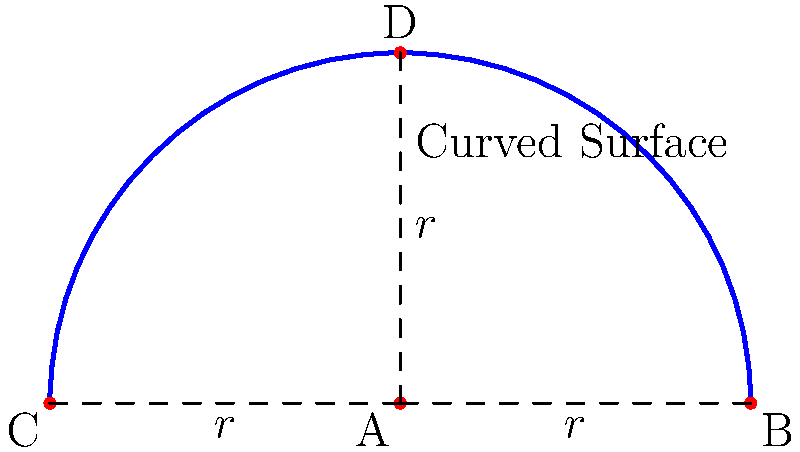In a geothermal energy extraction project, engineers are exploring a curved underground surface modeled as a hemisphere with radius $r$. If the surface area of this hemisphere is 150 square meters, what is the length of the circular base's diameter? Round your answer to the nearest meter. To solve this problem, we'll follow these steps:

1) The surface area of a hemisphere is given by the formula:
   $$A = 2\pi r^2$$

2) We're given that the surface area is 150 square meters, so:
   $$150 = 2\pi r^2$$

3) Divide both sides by $2\pi$:
   $$\frac{150}{2\pi} = r^2$$

4) Take the square root of both sides:
   $$r = \sqrt{\frac{150}{2\pi}}$$

5) Calculate the value of $r$:
   $$r \approx 4.8507 \text{ meters}$$

6) The diameter of the circular base is twice the radius:
   $$d = 2r \approx 2 * 4.8507 = 9.7014 \text{ meters}$$

7) Rounding to the nearest meter:
   $$d \approx 10 \text{ meters}$$

This diameter represents the width of the curved surface at its base, which is crucial for determining the potential geothermal energy extraction area.
Answer: 10 meters 